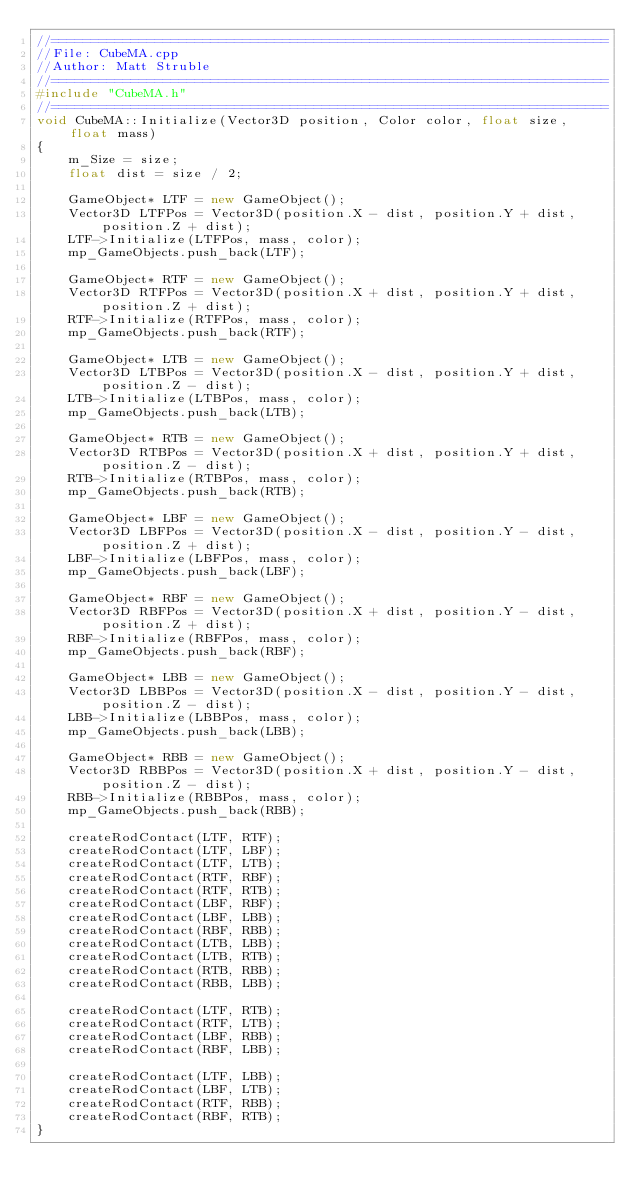Convert code to text. <code><loc_0><loc_0><loc_500><loc_500><_C++_>//======================================================================
//File: CubeMA.cpp
//Author: Matt Struble
//======================================================================
#include "CubeMA.h"
//======================================================================
void CubeMA::Initialize(Vector3D position, Color color, float size, float mass)
{
	m_Size = size;
	float dist = size / 2;

	GameObject* LTF = new GameObject();
	Vector3D LTFPos = Vector3D(position.X - dist, position.Y + dist, position.Z + dist);
	LTF->Initialize(LTFPos, mass, color);
	mp_GameObjects.push_back(LTF);

	GameObject* RTF = new GameObject();
	Vector3D RTFPos = Vector3D(position.X + dist, position.Y + dist, position.Z + dist);
	RTF->Initialize(RTFPos, mass, color);
	mp_GameObjects.push_back(RTF);

	GameObject* LTB = new GameObject();
	Vector3D LTBPos = Vector3D(position.X - dist, position.Y + dist, position.Z - dist);
	LTB->Initialize(LTBPos, mass, color);
	mp_GameObjects.push_back(LTB);

	GameObject* RTB = new GameObject();
	Vector3D RTBPos = Vector3D(position.X + dist, position.Y + dist, position.Z - dist);
	RTB->Initialize(RTBPos, mass, color);
	mp_GameObjects.push_back(RTB);

	GameObject* LBF = new GameObject();
	Vector3D LBFPos = Vector3D(position.X - dist, position.Y - dist, position.Z + dist);
	LBF->Initialize(LBFPos, mass, color);
	mp_GameObjects.push_back(LBF);

	GameObject* RBF = new GameObject();
	Vector3D RBFPos = Vector3D(position.X + dist, position.Y - dist, position.Z + dist);
	RBF->Initialize(RBFPos, mass, color);
	mp_GameObjects.push_back(RBF);

	GameObject* LBB = new GameObject();
	Vector3D LBBPos = Vector3D(position.X - dist, position.Y - dist, position.Z - dist);
	LBB->Initialize(LBBPos, mass, color);
	mp_GameObjects.push_back(LBB);

	GameObject* RBB = new GameObject();
	Vector3D RBBPos = Vector3D(position.X + dist, position.Y - dist, position.Z - dist);
	RBB->Initialize(RBBPos, mass, color);
	mp_GameObjects.push_back(RBB);

	createRodContact(LTF, RTF);
	createRodContact(LTF, LBF);
	createRodContact(LTF, LTB);
	createRodContact(RTF, RBF);
	createRodContact(RTF, RTB);
	createRodContact(LBF, RBF);
	createRodContact(LBF, LBB);
	createRodContact(RBF, RBB);
	createRodContact(LTB, LBB);
	createRodContact(LTB, RTB);
	createRodContact(RTB, RBB);
	createRodContact(RBB, LBB);

	createRodContact(LTF, RTB);
	createRodContact(RTF, LTB);
	createRodContact(LBF, RBB);
	createRodContact(RBF, LBB);

	createRodContact(LTF, LBB);
	createRodContact(LBF, LTB);
	createRodContact(RTF, RBB);
	createRodContact(RBF, RTB);
}</code> 